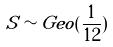Convert formula to latex. <formula><loc_0><loc_0><loc_500><loc_500>S \sim G e o ( \frac { 1 } { 1 2 } )</formula> 